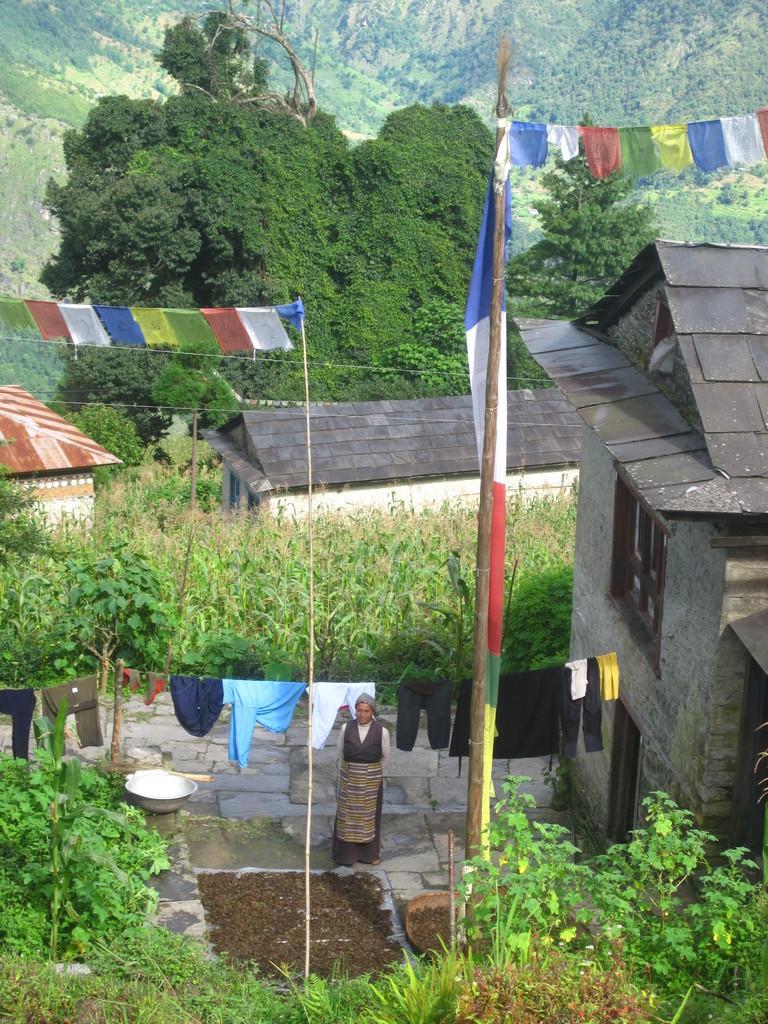Describe this image in one or two sentences. In the image in the center, we can see one person standing. And we can see poles, clothes, garlands, plants, baskets, buildings etc.. In the background we can see hills and trees. 